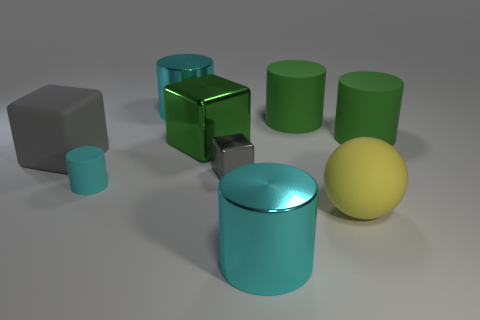How many rubber things are in front of the large metallic cylinder in front of the cyan rubber object?
Your answer should be compact. 0. What number of big gray things are made of the same material as the yellow thing?
Provide a short and direct response. 1. Are there any large cubes on the right side of the large rubber cube?
Provide a short and direct response. Yes. There is a matte block that is the same size as the ball; what color is it?
Offer a very short reply. Gray. How many things are small things left of the gray metal thing or large cubes?
Provide a short and direct response. 3. How big is the cylinder that is both behind the gray rubber object and to the left of the big green metal cube?
Give a very brief answer. Large. What size is the object that is the same color as the tiny block?
Your answer should be compact. Large. What number of other objects are the same size as the green shiny cube?
Offer a very short reply. 6. The metallic cylinder behind the large cyan metal thing in front of the large cyan thing that is to the left of the gray metallic block is what color?
Offer a very short reply. Cyan. What shape is the big thing that is both on the left side of the large yellow matte object and in front of the small cyan cylinder?
Provide a short and direct response. Cylinder. 